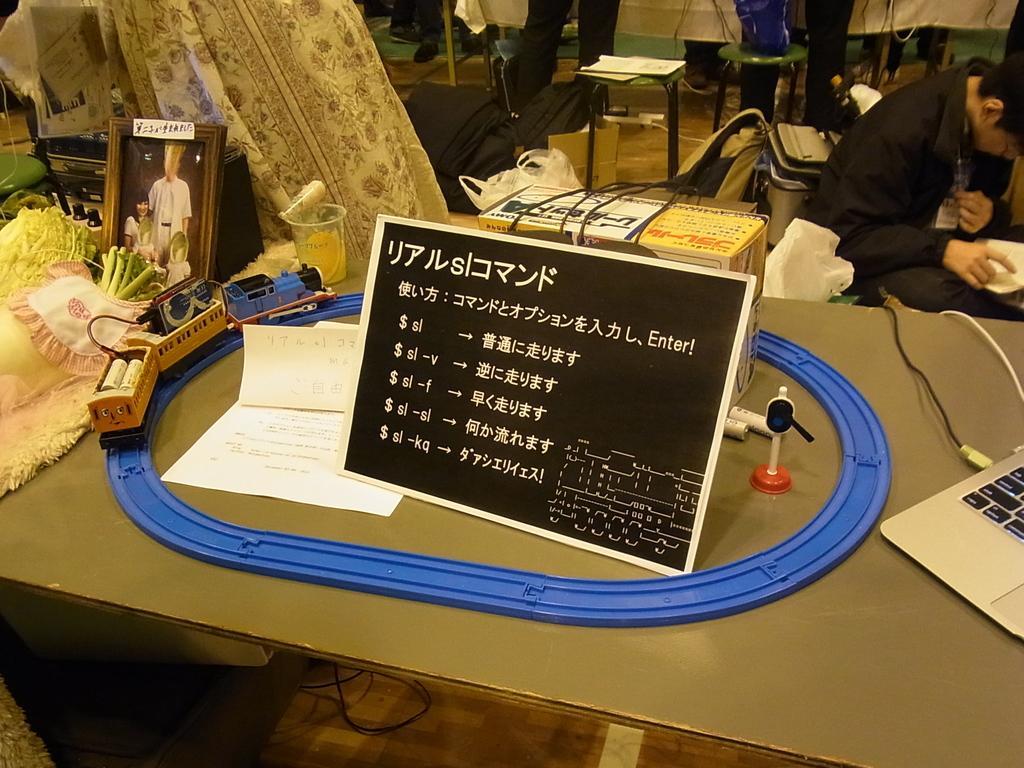Can you describe this image briefly? We can see board,papers,toy,photo frame,glass and things on the table. On the background we can see person and table,chair,cover. There is a person sitting on the chair. 